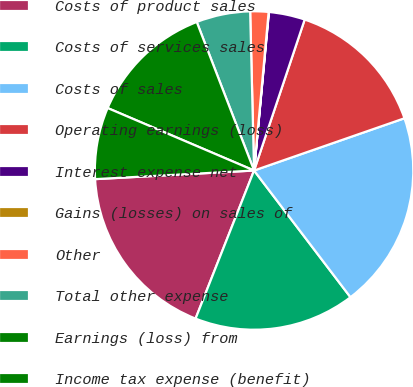Convert chart to OTSL. <chart><loc_0><loc_0><loc_500><loc_500><pie_chart><fcel>Costs of product sales<fcel>Costs of services sales<fcel>Costs of sales<fcel>Operating earnings (loss)<fcel>Interest expense net<fcel>Gains (losses) on sales of<fcel>Other<fcel>Total other expense<fcel>Earnings (loss) from<fcel>Income tax expense (benefit)<nl><fcel>18.15%<fcel>16.34%<fcel>19.97%<fcel>14.53%<fcel>3.66%<fcel>0.03%<fcel>1.85%<fcel>5.47%<fcel>12.72%<fcel>7.28%<nl></chart> 